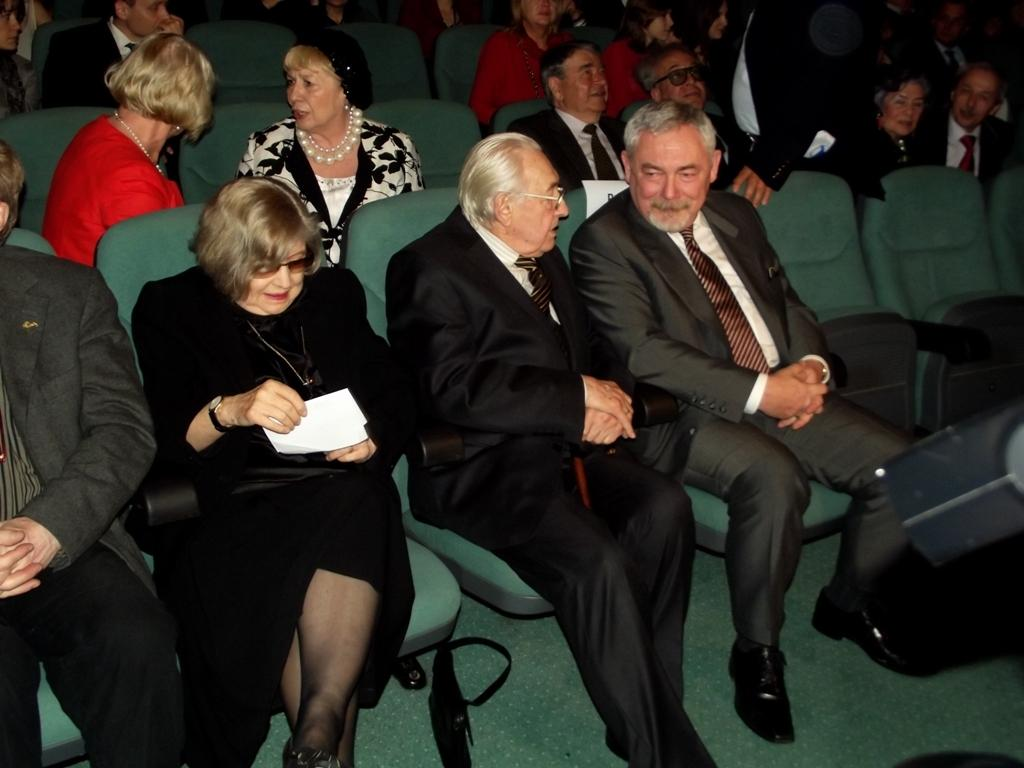What are the people in the image doing? The people in the image are sitting on chairs. How can you describe the clothing of the people in the image? The people are wearing different color dresses. Can you identify any specific action being performed by one of the people in the image? Yes, there is a person holding something in the image. What type of mint is being used to provide comfort to the people in the image? There is no mint or reference to comfort in the image; the people are simply sitting on chairs and wearing different color dresses. 